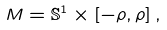<formula> <loc_0><loc_0><loc_500><loc_500>M = \mathbb { S } ^ { 1 } \times \left [ - \rho , \rho \right ] ,</formula> 